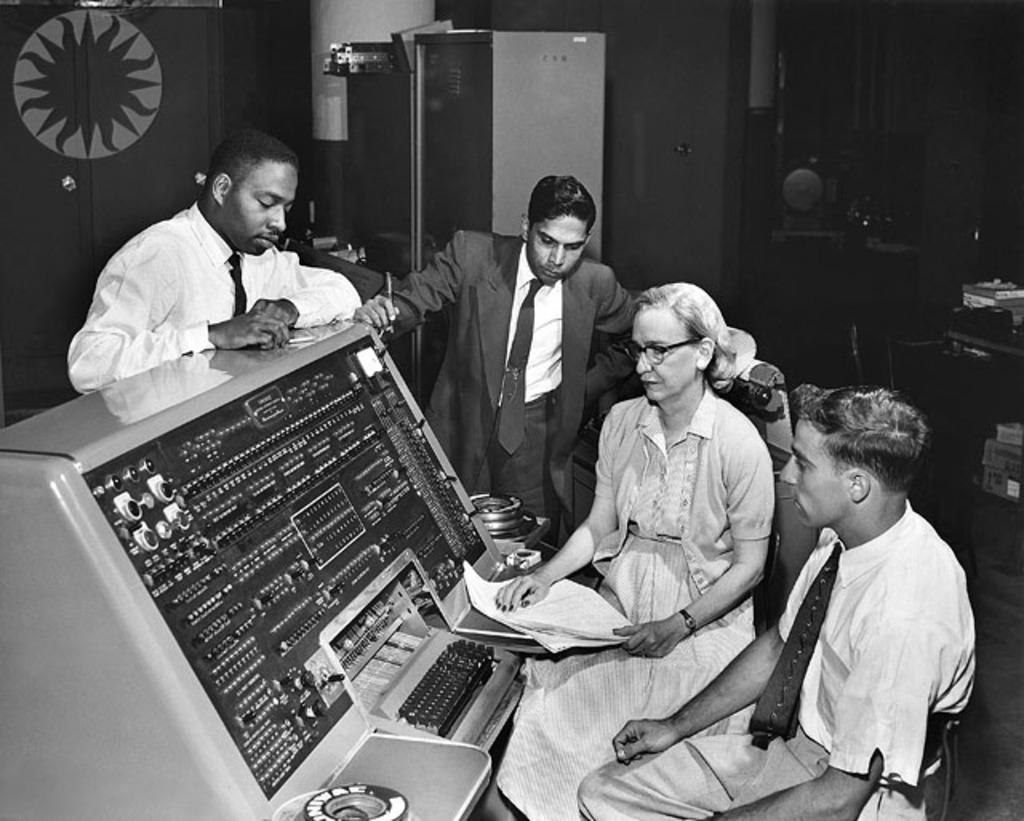How would you summarize this image in a sentence or two? In this image I can see four people. I can see two people are sitting and two are standing. In-front of these I can see the electronic equipment and there is a key board in-front of it. In the background I can see the cupboards and the books. This is a black and white image. 